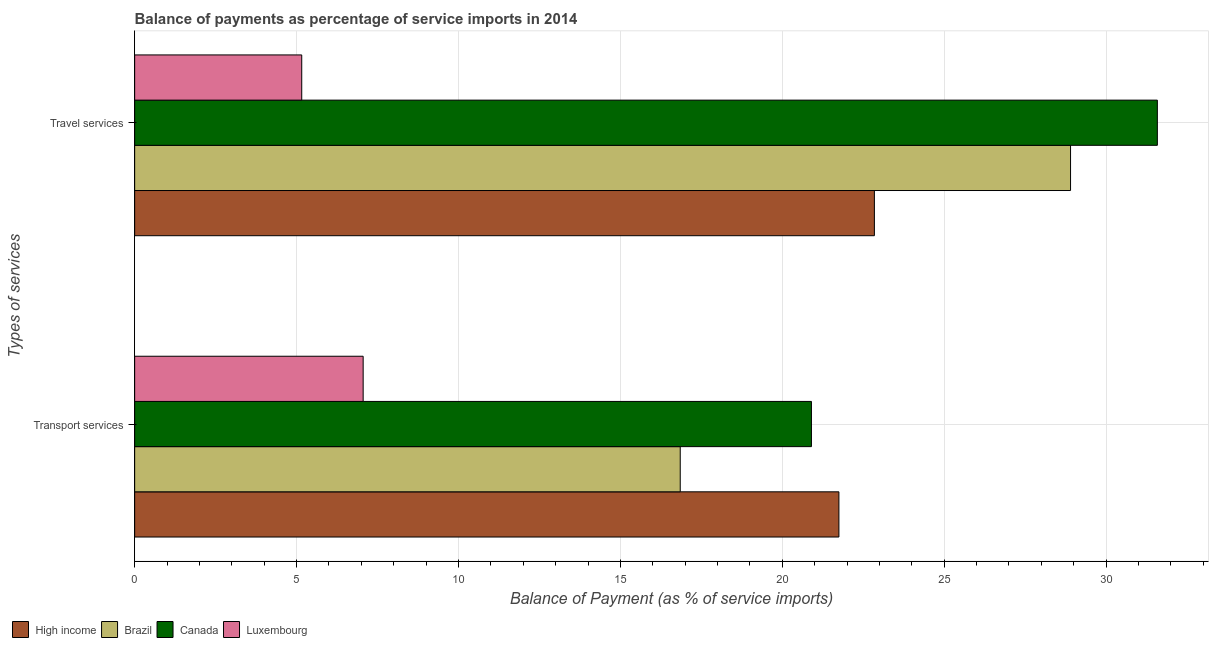How many different coloured bars are there?
Your answer should be very brief. 4. How many bars are there on the 1st tick from the top?
Give a very brief answer. 4. What is the label of the 2nd group of bars from the top?
Give a very brief answer. Transport services. What is the balance of payments of travel services in Canada?
Your response must be concise. 31.58. Across all countries, what is the maximum balance of payments of transport services?
Keep it short and to the point. 21.75. Across all countries, what is the minimum balance of payments of transport services?
Offer a very short reply. 7.06. In which country was the balance of payments of travel services maximum?
Keep it short and to the point. Canada. In which country was the balance of payments of travel services minimum?
Your response must be concise. Luxembourg. What is the total balance of payments of transport services in the graph?
Your response must be concise. 66.55. What is the difference between the balance of payments of travel services in Brazil and that in Luxembourg?
Your response must be concise. 23.74. What is the difference between the balance of payments of transport services in Brazil and the balance of payments of travel services in High income?
Ensure brevity in your answer.  -6. What is the average balance of payments of travel services per country?
Provide a short and direct response. 22.12. What is the difference between the balance of payments of travel services and balance of payments of transport services in Luxembourg?
Your response must be concise. -1.9. What is the ratio of the balance of payments of travel services in High income to that in Canada?
Give a very brief answer. 0.72. What does the 2nd bar from the top in Travel services represents?
Your response must be concise. Canada. What does the 4th bar from the bottom in Travel services represents?
Your answer should be very brief. Luxembourg. How many countries are there in the graph?
Ensure brevity in your answer.  4. What is the difference between two consecutive major ticks on the X-axis?
Your answer should be very brief. 5. Does the graph contain grids?
Provide a succinct answer. Yes. How many legend labels are there?
Your answer should be very brief. 4. How are the legend labels stacked?
Your response must be concise. Horizontal. What is the title of the graph?
Your response must be concise. Balance of payments as percentage of service imports in 2014. What is the label or title of the X-axis?
Give a very brief answer. Balance of Payment (as % of service imports). What is the label or title of the Y-axis?
Ensure brevity in your answer.  Types of services. What is the Balance of Payment (as % of service imports) of High income in Transport services?
Give a very brief answer. 21.75. What is the Balance of Payment (as % of service imports) of Brazil in Transport services?
Your answer should be compact. 16.85. What is the Balance of Payment (as % of service imports) in Canada in Transport services?
Your response must be concise. 20.9. What is the Balance of Payment (as % of service imports) in Luxembourg in Transport services?
Give a very brief answer. 7.06. What is the Balance of Payment (as % of service imports) of High income in Travel services?
Provide a succinct answer. 22.84. What is the Balance of Payment (as % of service imports) of Brazil in Travel services?
Provide a succinct answer. 28.9. What is the Balance of Payment (as % of service imports) of Canada in Travel services?
Offer a terse response. 31.58. What is the Balance of Payment (as % of service imports) in Luxembourg in Travel services?
Provide a short and direct response. 5.16. Across all Types of services, what is the maximum Balance of Payment (as % of service imports) in High income?
Provide a short and direct response. 22.84. Across all Types of services, what is the maximum Balance of Payment (as % of service imports) in Brazil?
Keep it short and to the point. 28.9. Across all Types of services, what is the maximum Balance of Payment (as % of service imports) of Canada?
Provide a short and direct response. 31.58. Across all Types of services, what is the maximum Balance of Payment (as % of service imports) of Luxembourg?
Ensure brevity in your answer.  7.06. Across all Types of services, what is the minimum Balance of Payment (as % of service imports) of High income?
Give a very brief answer. 21.75. Across all Types of services, what is the minimum Balance of Payment (as % of service imports) in Brazil?
Your answer should be compact. 16.85. Across all Types of services, what is the minimum Balance of Payment (as % of service imports) in Canada?
Offer a very short reply. 20.9. Across all Types of services, what is the minimum Balance of Payment (as % of service imports) of Luxembourg?
Keep it short and to the point. 5.16. What is the total Balance of Payment (as % of service imports) in High income in the graph?
Your answer should be compact. 44.59. What is the total Balance of Payment (as % of service imports) in Brazil in the graph?
Provide a succinct answer. 45.75. What is the total Balance of Payment (as % of service imports) in Canada in the graph?
Your response must be concise. 52.48. What is the total Balance of Payment (as % of service imports) of Luxembourg in the graph?
Your response must be concise. 12.22. What is the difference between the Balance of Payment (as % of service imports) of High income in Transport services and that in Travel services?
Ensure brevity in your answer.  -1.1. What is the difference between the Balance of Payment (as % of service imports) of Brazil in Transport services and that in Travel services?
Offer a terse response. -12.05. What is the difference between the Balance of Payment (as % of service imports) in Canada in Transport services and that in Travel services?
Offer a terse response. -10.68. What is the difference between the Balance of Payment (as % of service imports) in Luxembourg in Transport services and that in Travel services?
Provide a succinct answer. 1.9. What is the difference between the Balance of Payment (as % of service imports) in High income in Transport services and the Balance of Payment (as % of service imports) in Brazil in Travel services?
Your answer should be very brief. -7.15. What is the difference between the Balance of Payment (as % of service imports) in High income in Transport services and the Balance of Payment (as % of service imports) in Canada in Travel services?
Give a very brief answer. -9.83. What is the difference between the Balance of Payment (as % of service imports) in High income in Transport services and the Balance of Payment (as % of service imports) in Luxembourg in Travel services?
Offer a very short reply. 16.59. What is the difference between the Balance of Payment (as % of service imports) of Brazil in Transport services and the Balance of Payment (as % of service imports) of Canada in Travel services?
Make the answer very short. -14.73. What is the difference between the Balance of Payment (as % of service imports) of Brazil in Transport services and the Balance of Payment (as % of service imports) of Luxembourg in Travel services?
Offer a terse response. 11.69. What is the difference between the Balance of Payment (as % of service imports) of Canada in Transport services and the Balance of Payment (as % of service imports) of Luxembourg in Travel services?
Your answer should be very brief. 15.74. What is the average Balance of Payment (as % of service imports) in High income per Types of services?
Your answer should be compact. 22.3. What is the average Balance of Payment (as % of service imports) of Brazil per Types of services?
Provide a succinct answer. 22.87. What is the average Balance of Payment (as % of service imports) in Canada per Types of services?
Offer a very short reply. 26.24. What is the average Balance of Payment (as % of service imports) of Luxembourg per Types of services?
Ensure brevity in your answer.  6.11. What is the difference between the Balance of Payment (as % of service imports) of High income and Balance of Payment (as % of service imports) of Brazil in Transport services?
Make the answer very short. 4.9. What is the difference between the Balance of Payment (as % of service imports) of High income and Balance of Payment (as % of service imports) of Canada in Transport services?
Keep it short and to the point. 0.85. What is the difference between the Balance of Payment (as % of service imports) of High income and Balance of Payment (as % of service imports) of Luxembourg in Transport services?
Ensure brevity in your answer.  14.69. What is the difference between the Balance of Payment (as % of service imports) in Brazil and Balance of Payment (as % of service imports) in Canada in Transport services?
Your answer should be compact. -4.05. What is the difference between the Balance of Payment (as % of service imports) in Brazil and Balance of Payment (as % of service imports) in Luxembourg in Transport services?
Provide a short and direct response. 9.79. What is the difference between the Balance of Payment (as % of service imports) in Canada and Balance of Payment (as % of service imports) in Luxembourg in Transport services?
Your answer should be very brief. 13.84. What is the difference between the Balance of Payment (as % of service imports) in High income and Balance of Payment (as % of service imports) in Brazil in Travel services?
Ensure brevity in your answer.  -6.06. What is the difference between the Balance of Payment (as % of service imports) in High income and Balance of Payment (as % of service imports) in Canada in Travel services?
Offer a terse response. -8.74. What is the difference between the Balance of Payment (as % of service imports) of High income and Balance of Payment (as % of service imports) of Luxembourg in Travel services?
Make the answer very short. 17.68. What is the difference between the Balance of Payment (as % of service imports) of Brazil and Balance of Payment (as % of service imports) of Canada in Travel services?
Offer a terse response. -2.68. What is the difference between the Balance of Payment (as % of service imports) of Brazil and Balance of Payment (as % of service imports) of Luxembourg in Travel services?
Your answer should be compact. 23.74. What is the difference between the Balance of Payment (as % of service imports) of Canada and Balance of Payment (as % of service imports) of Luxembourg in Travel services?
Provide a succinct answer. 26.42. What is the ratio of the Balance of Payment (as % of service imports) of High income in Transport services to that in Travel services?
Make the answer very short. 0.95. What is the ratio of the Balance of Payment (as % of service imports) of Brazil in Transport services to that in Travel services?
Provide a succinct answer. 0.58. What is the ratio of the Balance of Payment (as % of service imports) of Canada in Transport services to that in Travel services?
Provide a succinct answer. 0.66. What is the ratio of the Balance of Payment (as % of service imports) of Luxembourg in Transport services to that in Travel services?
Your answer should be compact. 1.37. What is the difference between the highest and the second highest Balance of Payment (as % of service imports) in High income?
Your answer should be compact. 1.1. What is the difference between the highest and the second highest Balance of Payment (as % of service imports) in Brazil?
Your answer should be compact. 12.05. What is the difference between the highest and the second highest Balance of Payment (as % of service imports) of Canada?
Give a very brief answer. 10.68. What is the difference between the highest and the second highest Balance of Payment (as % of service imports) in Luxembourg?
Ensure brevity in your answer.  1.9. What is the difference between the highest and the lowest Balance of Payment (as % of service imports) of High income?
Make the answer very short. 1.1. What is the difference between the highest and the lowest Balance of Payment (as % of service imports) in Brazil?
Keep it short and to the point. 12.05. What is the difference between the highest and the lowest Balance of Payment (as % of service imports) in Canada?
Make the answer very short. 10.68. What is the difference between the highest and the lowest Balance of Payment (as % of service imports) of Luxembourg?
Provide a succinct answer. 1.9. 